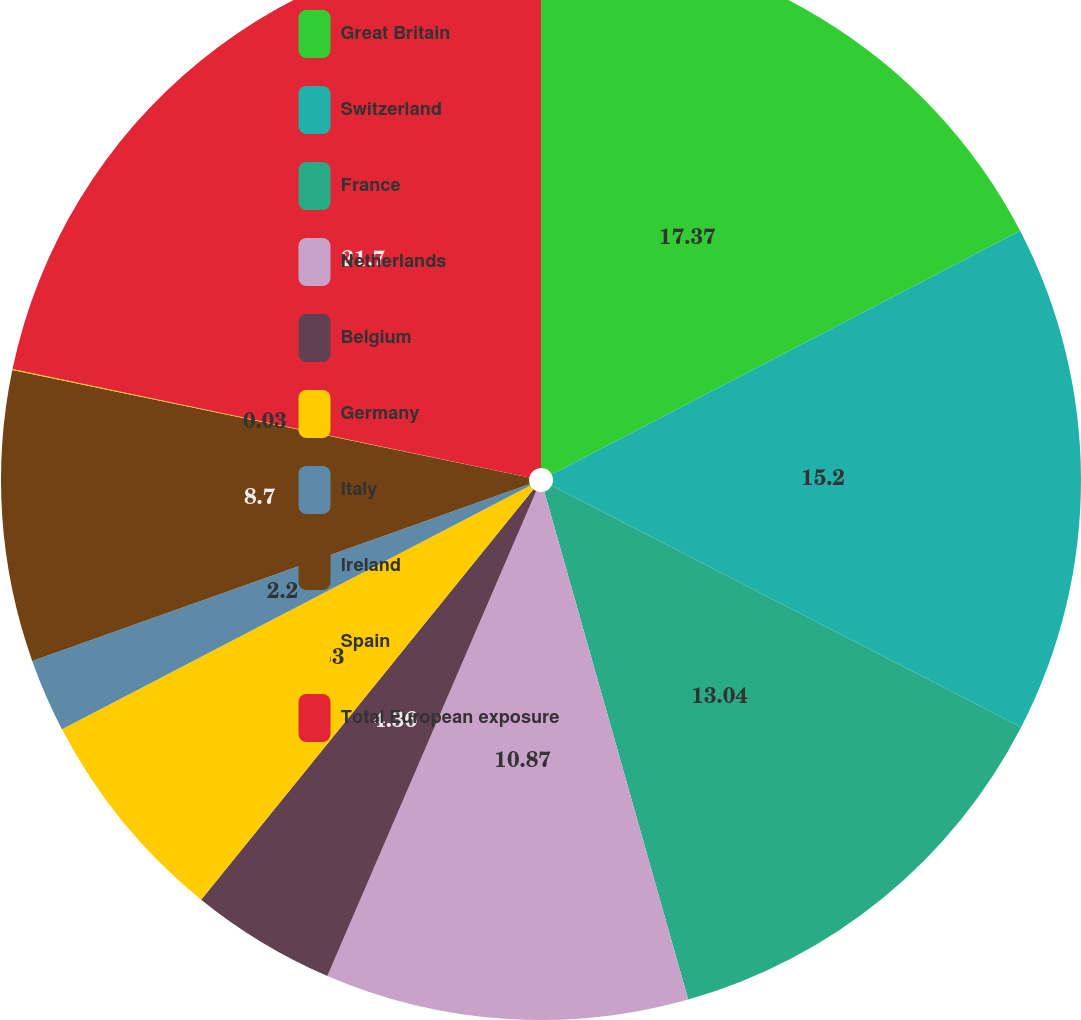Convert chart to OTSL. <chart><loc_0><loc_0><loc_500><loc_500><pie_chart><fcel>Great Britain<fcel>Switzerland<fcel>France<fcel>Netherlands<fcel>Belgium<fcel>Germany<fcel>Italy<fcel>Ireland<fcel>Spain<fcel>Total European exposure<nl><fcel>17.37%<fcel>15.2%<fcel>13.04%<fcel>10.87%<fcel>4.36%<fcel>6.53%<fcel>2.2%<fcel>8.7%<fcel>0.03%<fcel>21.71%<nl></chart> 